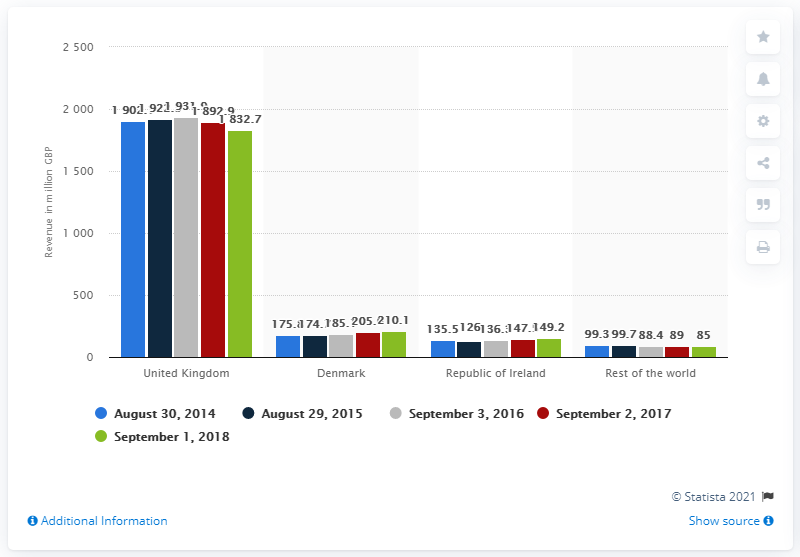Outline some significant characteristics in this image. Debenhams' revenue in the United Kingdom for the year ending September 1st, 2018, was 1832.7 million pounds. 